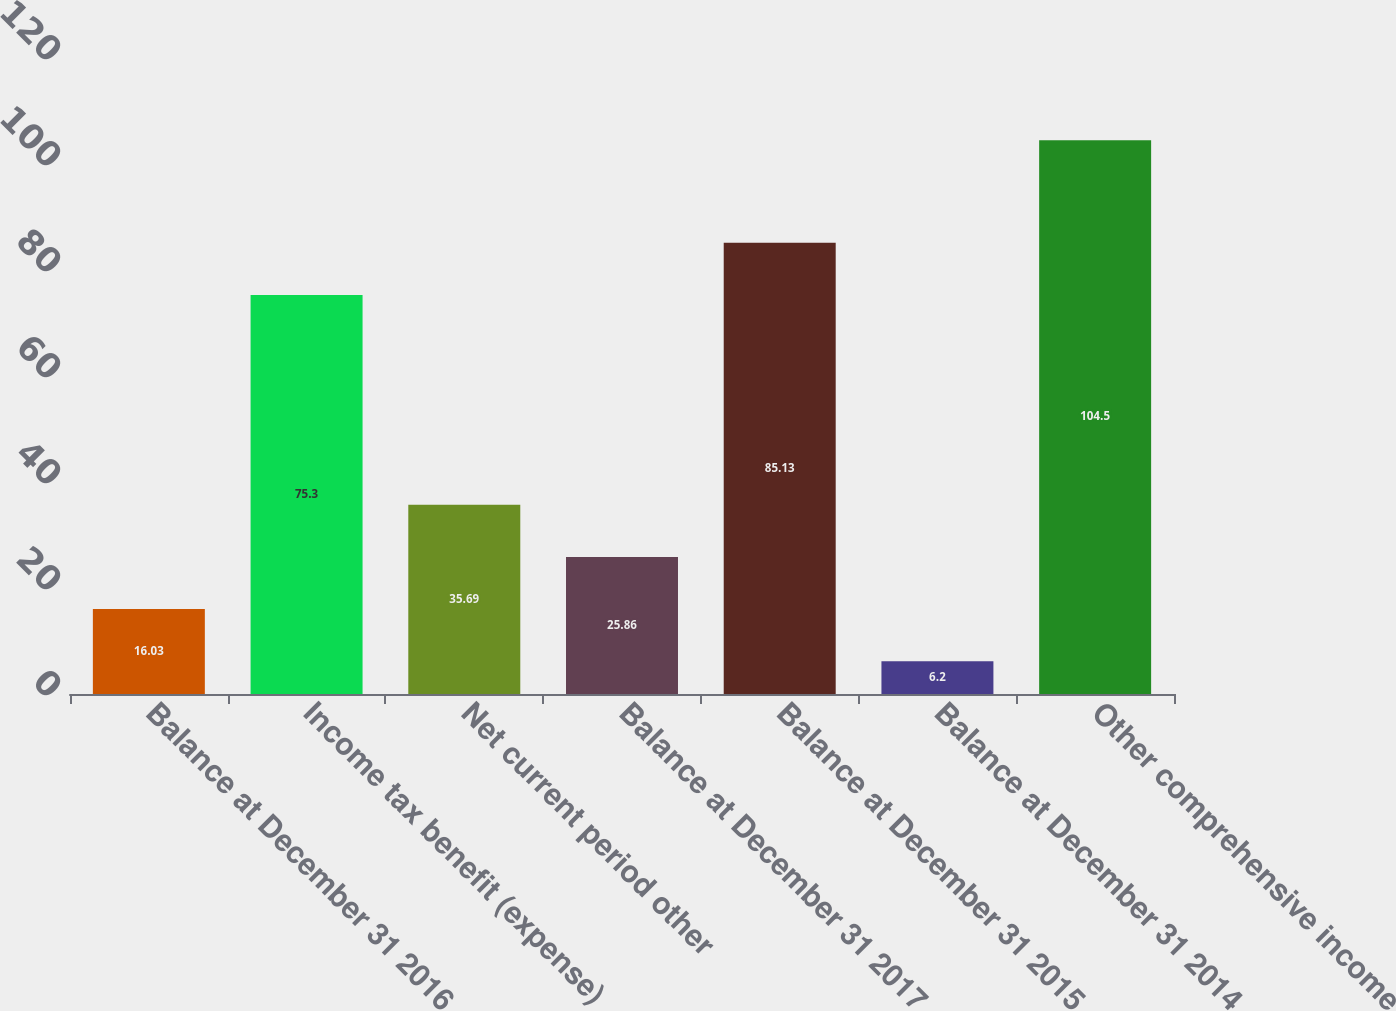Convert chart. <chart><loc_0><loc_0><loc_500><loc_500><bar_chart><fcel>Balance at December 31 2016<fcel>Income tax benefit (expense)<fcel>Net current period other<fcel>Balance at December 31 2017<fcel>Balance at December 31 2015<fcel>Balance at December 31 2014<fcel>Other comprehensive income<nl><fcel>16.03<fcel>75.3<fcel>35.69<fcel>25.86<fcel>85.13<fcel>6.2<fcel>104.5<nl></chart> 